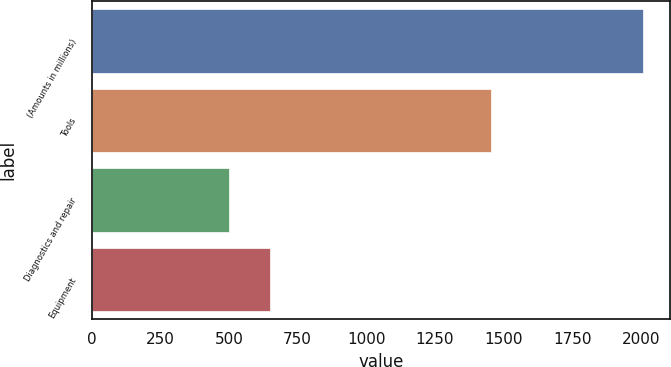<chart> <loc_0><loc_0><loc_500><loc_500><bar_chart><fcel>(Amounts in millions)<fcel>Tools<fcel>Diagnostics and repair<fcel>Equipment<nl><fcel>2006<fcel>1453.1<fcel>499.5<fcel>650.15<nl></chart> 